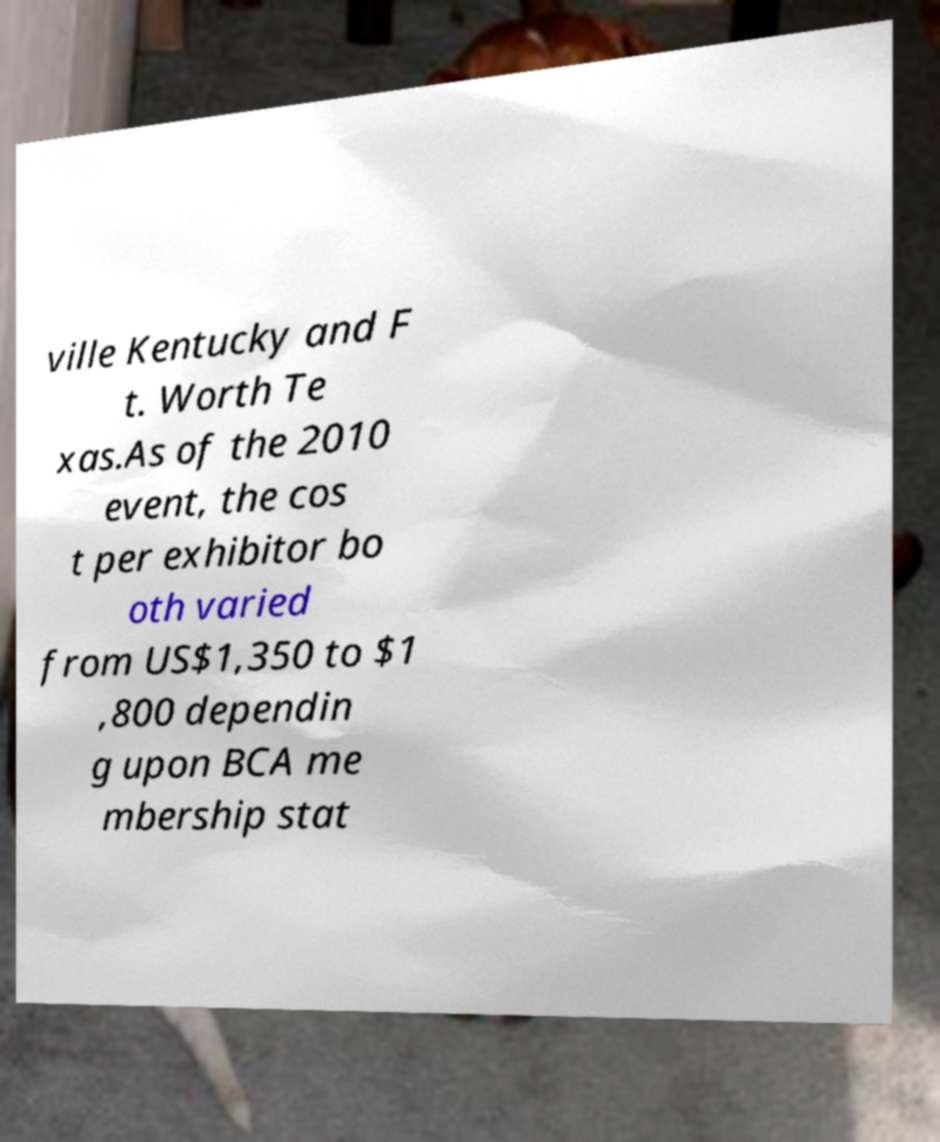There's text embedded in this image that I need extracted. Can you transcribe it verbatim? ville Kentucky and F t. Worth Te xas.As of the 2010 event, the cos t per exhibitor bo oth varied from US$1,350 to $1 ,800 dependin g upon BCA me mbership stat 